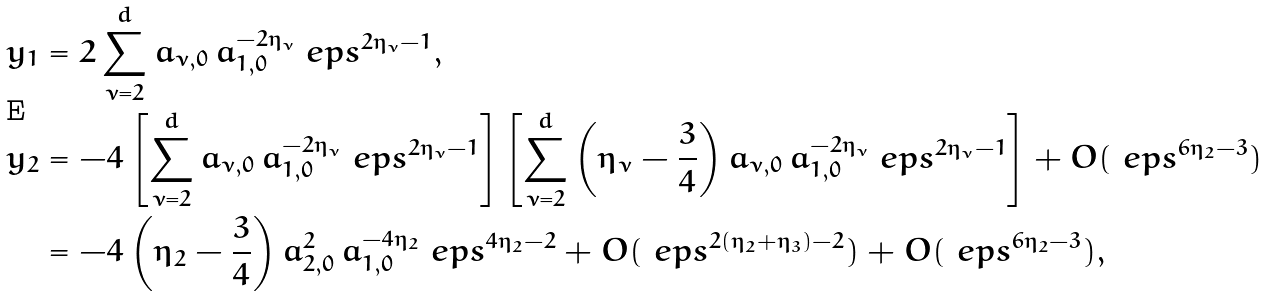Convert formula to latex. <formula><loc_0><loc_0><loc_500><loc_500>y _ { 1 } & = 2 \sum _ { \nu = 2 } ^ { d } a _ { \nu , 0 } \, a _ { 1 , 0 } ^ { - 2 \eta _ { \nu } } \ e p s ^ { 2 \eta _ { \nu } - 1 } , \\ y _ { 2 } & = - 4 \left [ \sum _ { \nu = 2 } ^ { d } a _ { \nu , 0 } \, a _ { 1 , 0 } ^ { - 2 \eta _ { \nu } } \ e p s ^ { 2 \eta _ { \nu } - 1 } \right ] \left [ \sum _ { \nu = 2 } ^ { d } \left ( \eta _ { \nu } - \frac { 3 } { 4 } \right ) a _ { \nu , 0 } \, a _ { 1 , 0 } ^ { - 2 \eta _ { \nu } } \ e p s ^ { 2 \eta _ { \nu } - 1 } \right ] + O ( \ e p s ^ { 6 \eta _ { 2 } - 3 } ) \\ & = - 4 \left ( \eta _ { 2 } - \frac { 3 } { 4 } \right ) a _ { 2 , 0 } ^ { 2 } \, a _ { 1 , 0 } ^ { - 4 \eta _ { 2 } } \ e p s ^ { 4 \eta _ { 2 } - 2 } + O ( \ e p s ^ { 2 ( \eta _ { 2 } + \eta _ { 3 } ) - 2 } ) + O ( \ e p s ^ { 6 \eta _ { 2 } - 3 } ) ,</formula> 